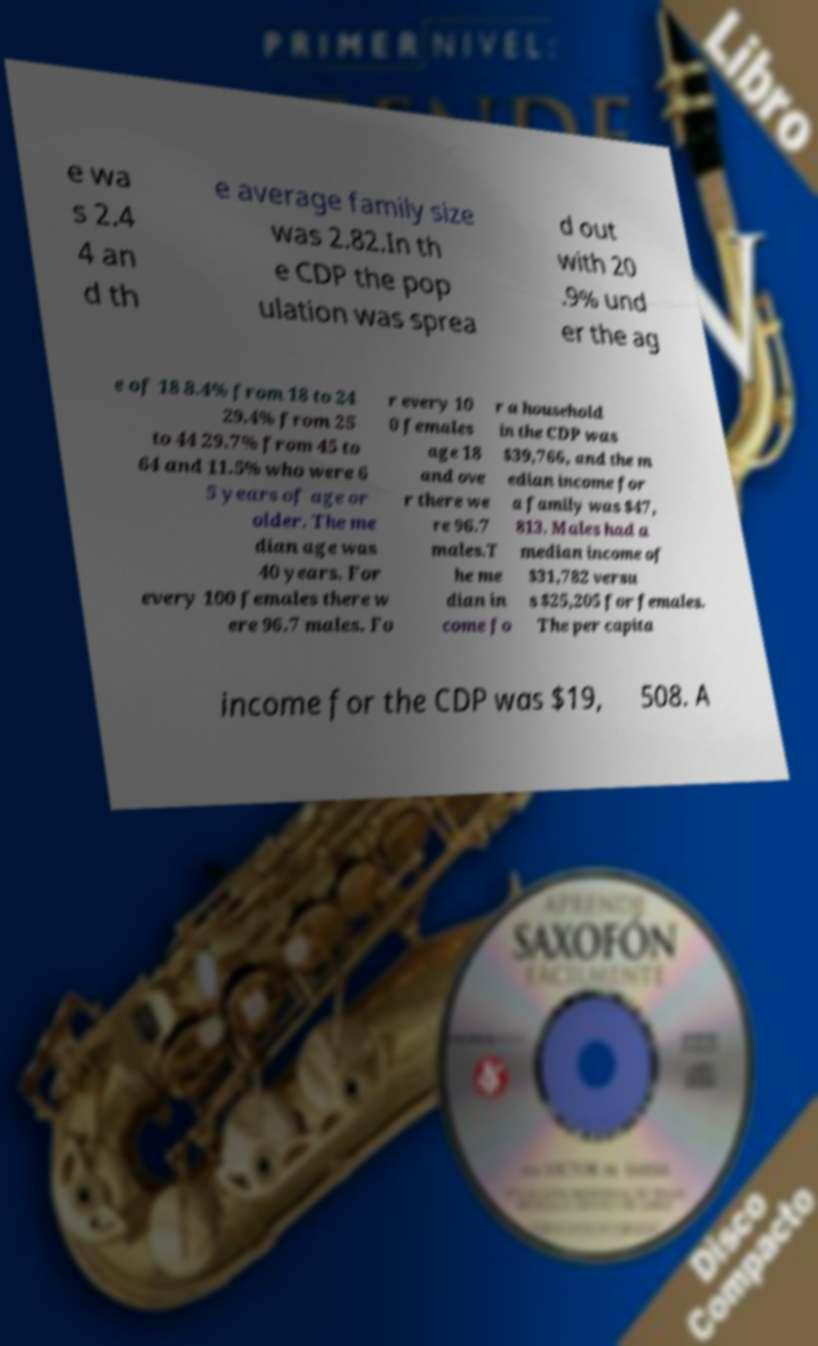What messages or text are displayed in this image? I need them in a readable, typed format. e wa s 2.4 4 an d th e average family size was 2.82.In th e CDP the pop ulation was sprea d out with 20 .9% und er the ag e of 18 8.4% from 18 to 24 29.4% from 25 to 44 29.7% from 45 to 64 and 11.5% who were 6 5 years of age or older. The me dian age was 40 years. For every 100 females there w ere 96.7 males. Fo r every 10 0 females age 18 and ove r there we re 96.7 males.T he me dian in come fo r a household in the CDP was $39,766, and the m edian income for a family was $47, 813. Males had a median income of $31,782 versu s $25,205 for females. The per capita income for the CDP was $19, 508. A 